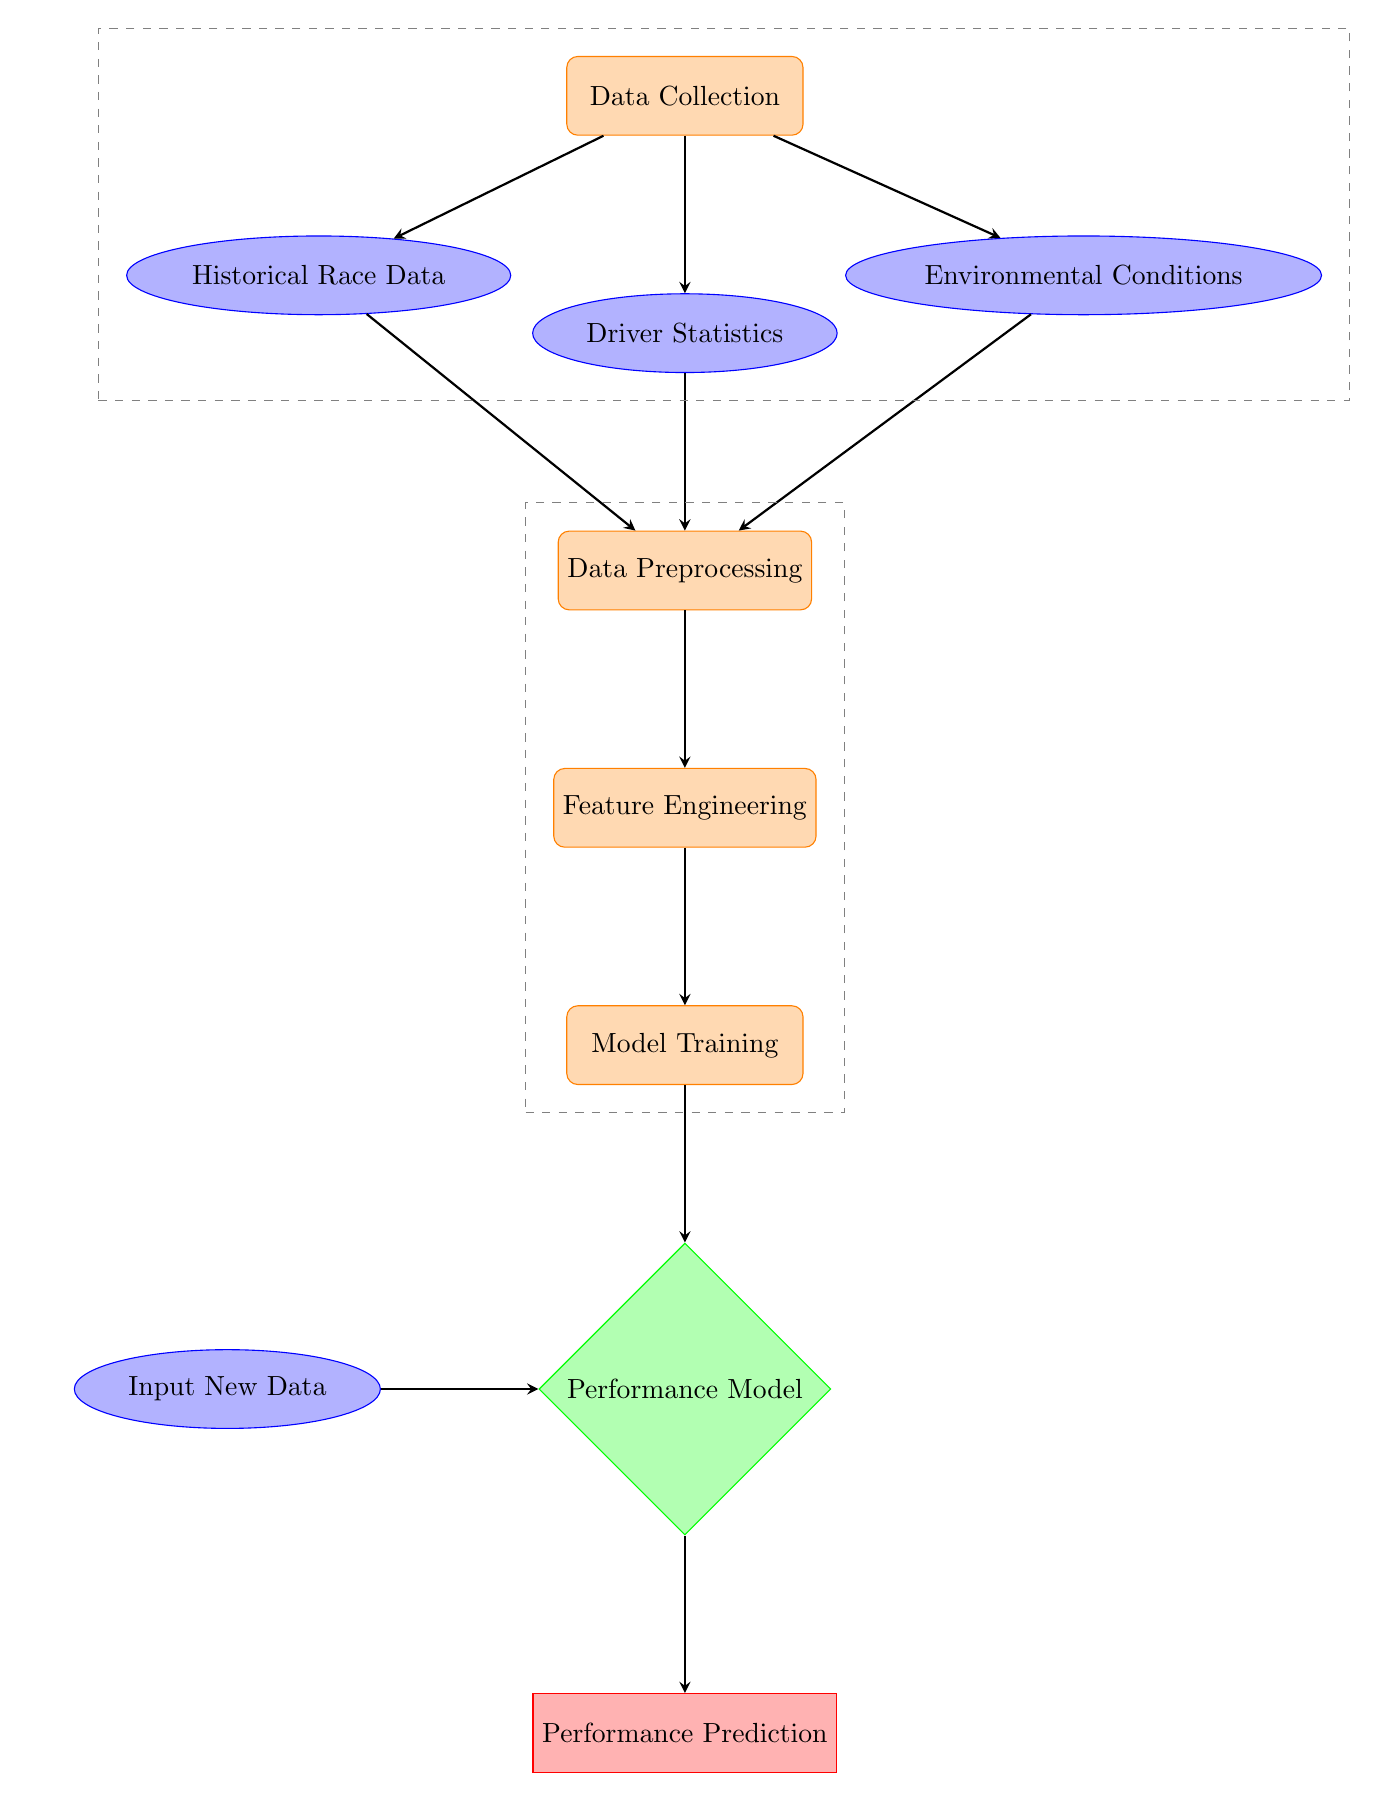What is the first process in the diagram? The first process, as indicated by the topmost rectangle, is labeled "Data Collection."
Answer: Data Collection How many types of data are collected according to the diagram? The diagram shows three types of data: "Historical Race Data," "Driver Statistics," and "Environmental Conditions." Counting these gives a total of three types.
Answer: Three Which node processes the data collected from drivers and environmental conditions? The node labeled "Data Preprocessing" handles the data from "Driver Statistics" and "Environmental Conditions," as indicated by the arrows leading into it from those nodes.
Answer: Data Preprocessing What is the output of the model labelled "Performance Model"? The output from the "Performance Model" is labeled as "Performance Prediction," which is directly below it in the diagram.
Answer: Performance Prediction Identify the relationship between "Feature Engineering" and "Model Training." "Feature Engineering" feeds directly into "Model Training," indicated by the arrow connecting the two nodes in a downward direction.
Answer: Feature Engineering → Model Training What is the purpose of the "Input New Data" node? The "Input New Data" node serves to provide additional data to the "Performance Model," as shown by the arrow pointing from it to the model.
Answer: Provide additional data How many main processes are there in this diagram? Counting the rectangles marked as processes: "Data Collection," "Data Preprocessing," "Feature Engineering," "Model Training," and finally, the output node "Performance Prediction," shows there are four main processes.
Answer: Four Which model is used to predict performance? The model responsible for predicting performance is labeled "Performance Model," indicated by its diamond shape in the diagram.
Answer: Performance Model Describe what happens in the "Feature Engineering" step. The "Feature Engineering" step takes the results from "Data Preprocessing" and prepares features for the "Model Training," signifying important data transformation occurs here.
Answer: Prepares features for training What are the three types of input data contributed to the model? The model inputs come from "Historical Race Data," "Driver Statistics," and "Environmental Conditions," providing a comprehensive basis for performance predictions.
Answer: Historical Race Data, Driver Statistics, Environmental Conditions 